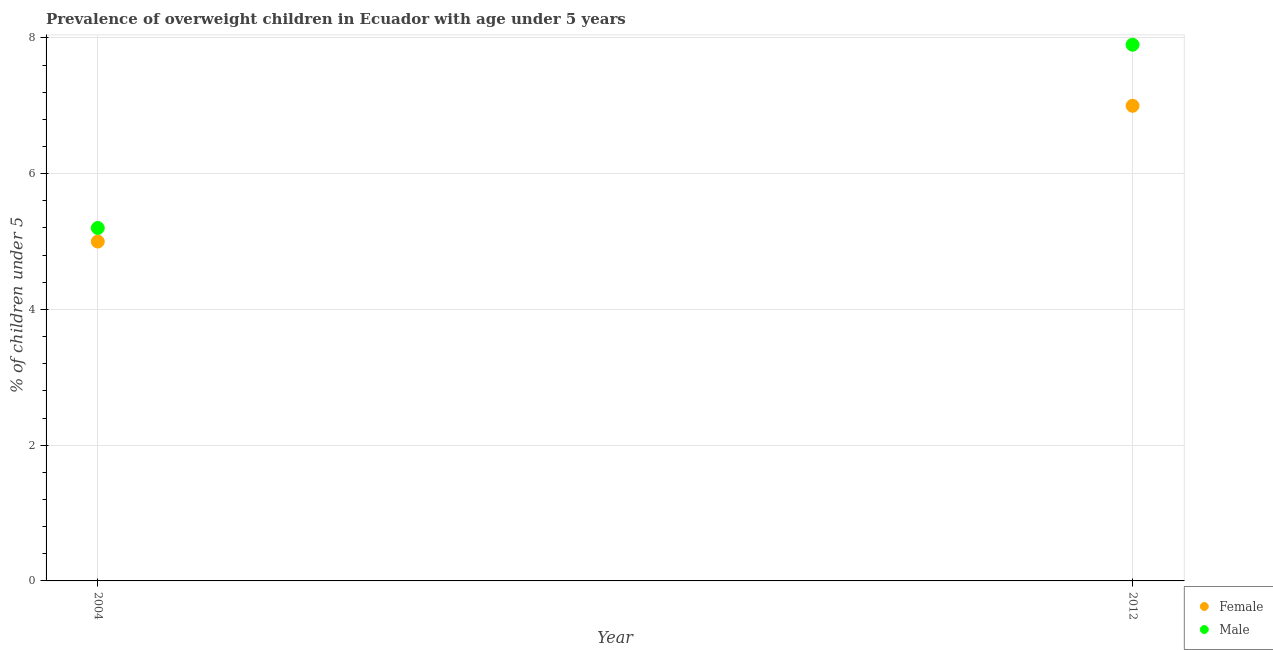What is the percentage of obese female children in 2004?
Your answer should be very brief. 5. Across all years, what is the maximum percentage of obese female children?
Provide a short and direct response. 7. Across all years, what is the minimum percentage of obese female children?
Your answer should be very brief. 5. In which year was the percentage of obese female children maximum?
Provide a succinct answer. 2012. What is the total percentage of obese female children in the graph?
Ensure brevity in your answer.  12. What is the difference between the percentage of obese male children in 2004 and that in 2012?
Provide a short and direct response. -2.7. What is the difference between the percentage of obese male children in 2012 and the percentage of obese female children in 2004?
Give a very brief answer. 2.9. In the year 2004, what is the difference between the percentage of obese female children and percentage of obese male children?
Offer a very short reply. -0.2. What is the ratio of the percentage of obese male children in 2004 to that in 2012?
Provide a short and direct response. 0.66. Is the percentage of obese female children in 2004 less than that in 2012?
Your answer should be very brief. Yes. In how many years, is the percentage of obese male children greater than the average percentage of obese male children taken over all years?
Your response must be concise. 1. Does the percentage of obese female children monotonically increase over the years?
Your response must be concise. Yes. Is the percentage of obese male children strictly greater than the percentage of obese female children over the years?
Provide a succinct answer. Yes. Is the percentage of obese female children strictly less than the percentage of obese male children over the years?
Keep it short and to the point. Yes. How many dotlines are there?
Your answer should be very brief. 2. How many years are there in the graph?
Your answer should be compact. 2. Are the values on the major ticks of Y-axis written in scientific E-notation?
Keep it short and to the point. No. Does the graph contain any zero values?
Keep it short and to the point. No. Does the graph contain grids?
Ensure brevity in your answer.  Yes. Where does the legend appear in the graph?
Make the answer very short. Bottom right. What is the title of the graph?
Offer a very short reply. Prevalence of overweight children in Ecuador with age under 5 years. Does "ODA received" appear as one of the legend labels in the graph?
Ensure brevity in your answer.  No. What is the label or title of the Y-axis?
Offer a very short reply.  % of children under 5. What is the  % of children under 5 in Female in 2004?
Your answer should be compact. 5. What is the  % of children under 5 of Male in 2004?
Your response must be concise. 5.2. What is the  % of children under 5 in Male in 2012?
Your answer should be very brief. 7.9. Across all years, what is the maximum  % of children under 5 in Male?
Provide a succinct answer. 7.9. Across all years, what is the minimum  % of children under 5 of Female?
Your response must be concise. 5. Across all years, what is the minimum  % of children under 5 of Male?
Your response must be concise. 5.2. What is the difference between the  % of children under 5 of Female in 2004 and that in 2012?
Keep it short and to the point. -2. What is the difference between the  % of children under 5 of Female in 2004 and the  % of children under 5 of Male in 2012?
Ensure brevity in your answer.  -2.9. What is the average  % of children under 5 of Male per year?
Ensure brevity in your answer.  6.55. In the year 2012, what is the difference between the  % of children under 5 of Female and  % of children under 5 of Male?
Keep it short and to the point. -0.9. What is the ratio of the  % of children under 5 of Male in 2004 to that in 2012?
Offer a terse response. 0.66. What is the difference between the highest and the second highest  % of children under 5 in Female?
Offer a very short reply. 2. What is the difference between the highest and the second highest  % of children under 5 of Male?
Your answer should be compact. 2.7. What is the difference between the highest and the lowest  % of children under 5 of Male?
Your response must be concise. 2.7. 